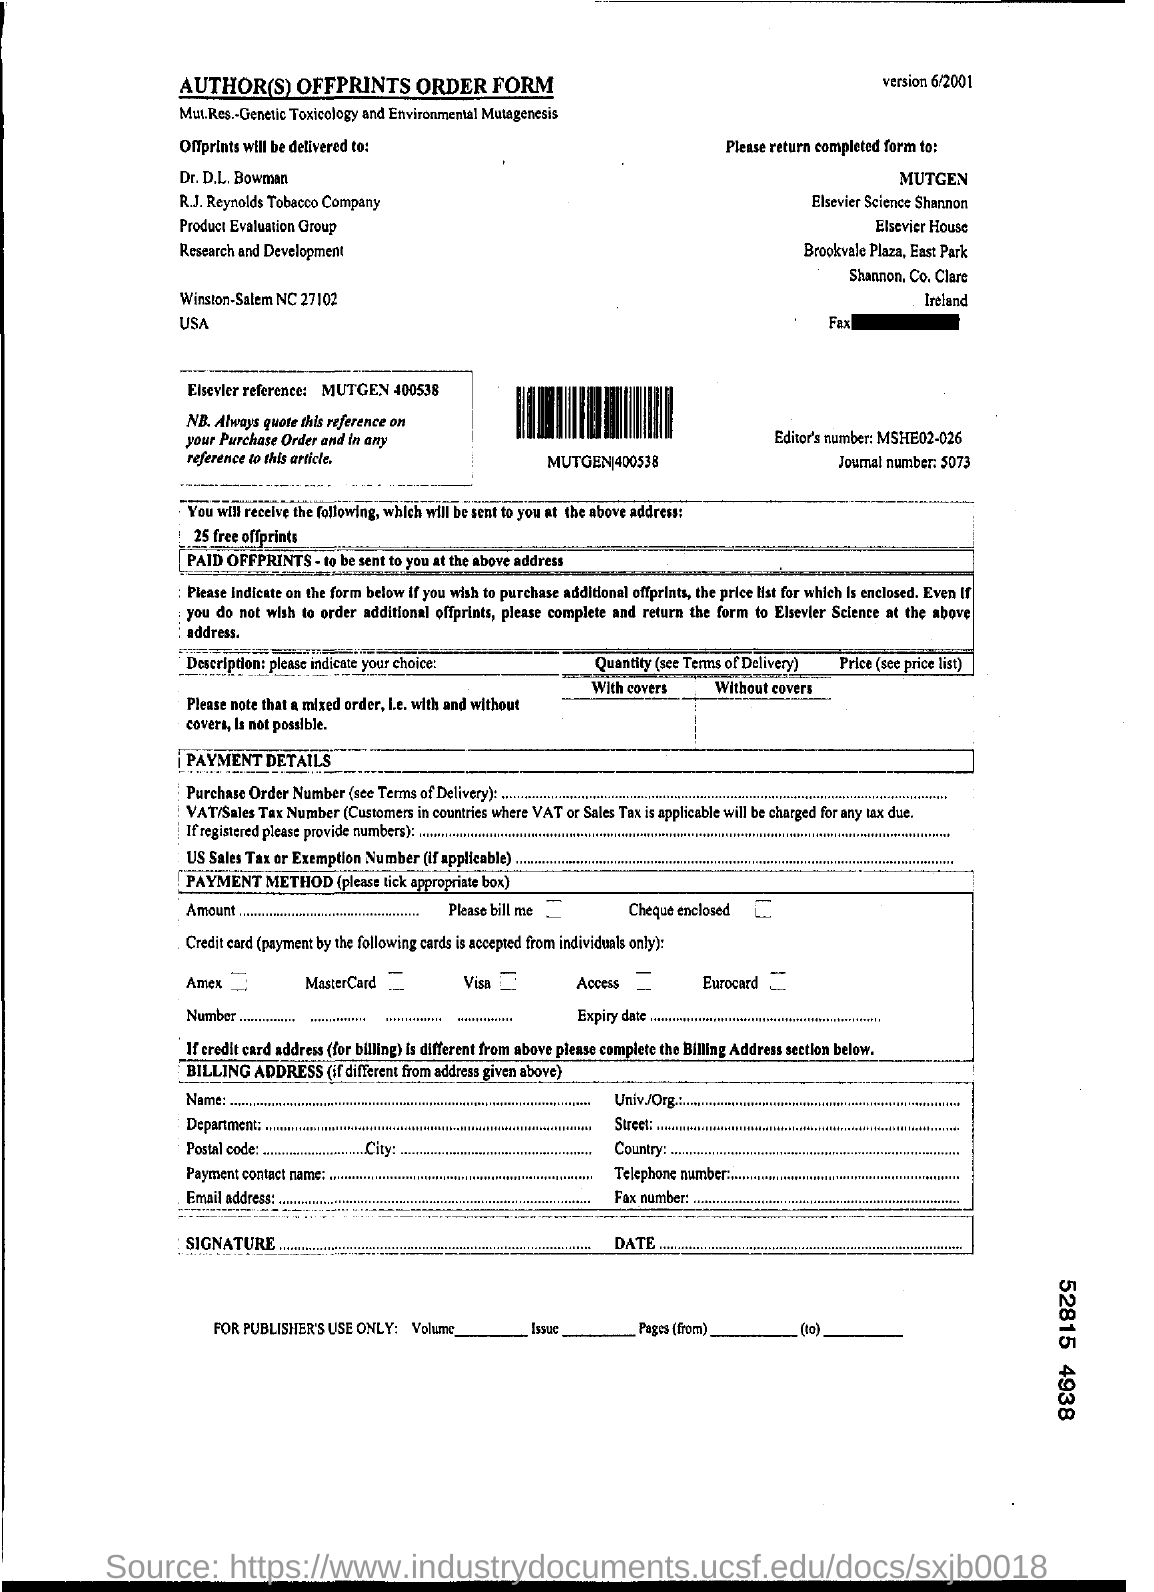Mention a couple of crucial points in this snapshot. The Editor's number is MSHE02-026. The offprints will be delivered to Dr. D.L. Bowman. The journal number is 5073. 